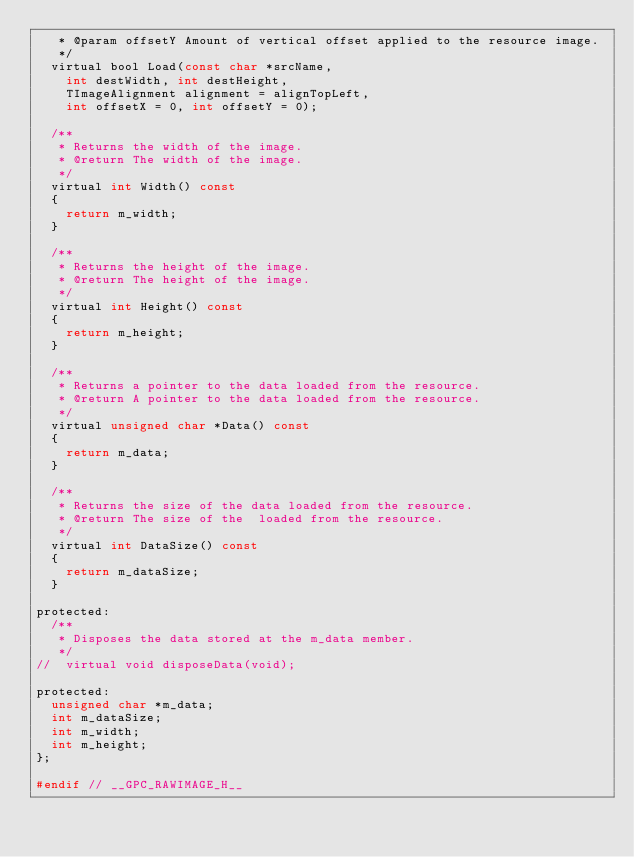Convert code to text. <code><loc_0><loc_0><loc_500><loc_500><_C_>	 * @param offsetY	Amount of vertical offset applied to the resource image.
	 */
	virtual bool Load(const char *srcName,
		int destWidth, int destHeight,
		TImageAlignment alignment = alignTopLeft,
		int offsetX = 0, int offsetY = 0);

	/**
	 * Returns the width of the image.
	 * @return The width of the image.
	 */
	virtual int Width() const
	{
		return m_width;
	}

	/**
	 * Returns the height of the image.
	 * @return The height of the image.
	 */
	virtual int Height() const
	{
		return m_height;
	}

	/**
	 * Returns a pointer to the data loaded from the resource.
	 * @return A pointer to the data loaded from the resource.
	 */
	virtual unsigned char *Data() const
	{
		return m_data;
	}

	/**
	 * Returns the size of the data loaded from the resource.
	 * @return The size of the  loaded from the resource.
	 */
	virtual int DataSize() const
	{
		return m_dataSize;
	}

protected:
	/**
	 * Disposes the data stored at the m_data member.
	 */
//	virtual void disposeData(void);

protected:
	unsigned char *m_data;
	int m_dataSize;
	int m_width;
	int m_height;
};

#endif // __GPC_RAWIMAGE_H__

</code> 